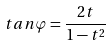<formula> <loc_0><loc_0><loc_500><loc_500>t a n \varphi = \frac { 2 t } { 1 - t ^ { 2 } }</formula> 